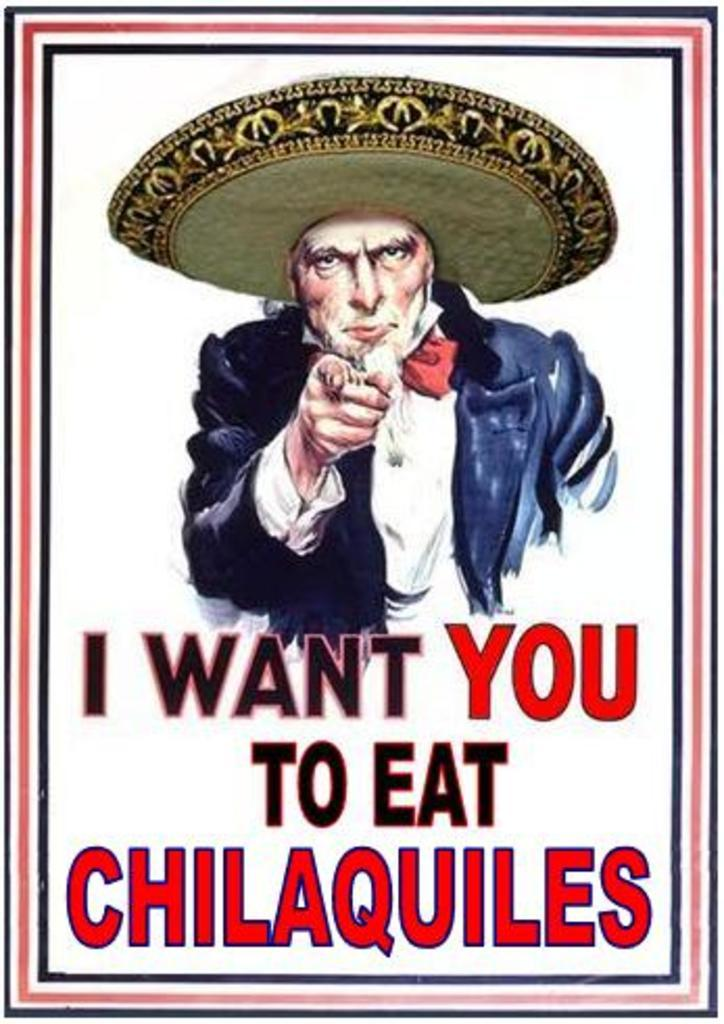Who is the main subject in the image? There is a man in the center of the image. What is the man wearing on his head? The man is wearing a hat. Can you describe any text that is visible in the image? Yes, there is visible text is present in the image. What feature surrounds the image? The image has borders. How many lizards can be seen crawling on the man's vest in the image? There are no lizards present in the image, and the man is not wearing a vest. What type of machine is visible in the background of the image? There is no machine visible in the image. 